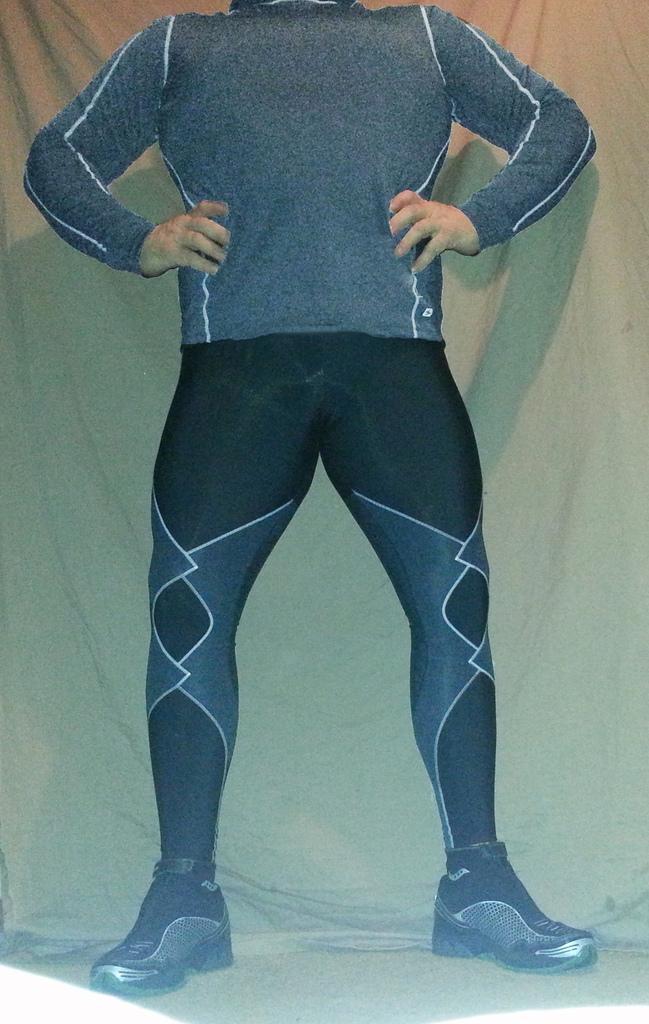Please provide a concise description of this image. In this image, I can see a person standing. In the background, that looks like a cloth. 